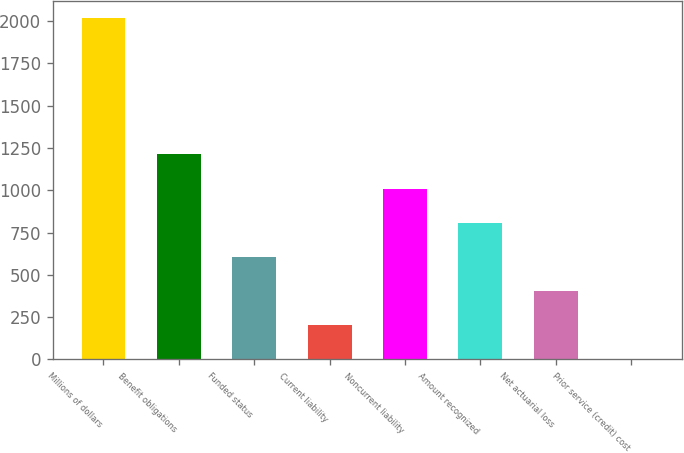Convert chart. <chart><loc_0><loc_0><loc_500><loc_500><bar_chart><fcel>Millions of dollars<fcel>Benefit obligations<fcel>Funded status<fcel>Current liability<fcel>Noncurrent liability<fcel>Amount recognized<fcel>Net actuarial loss<fcel>Prior service (credit) cost<nl><fcel>2018<fcel>1211.6<fcel>606.8<fcel>203.6<fcel>1010<fcel>808.4<fcel>405.2<fcel>2<nl></chart> 